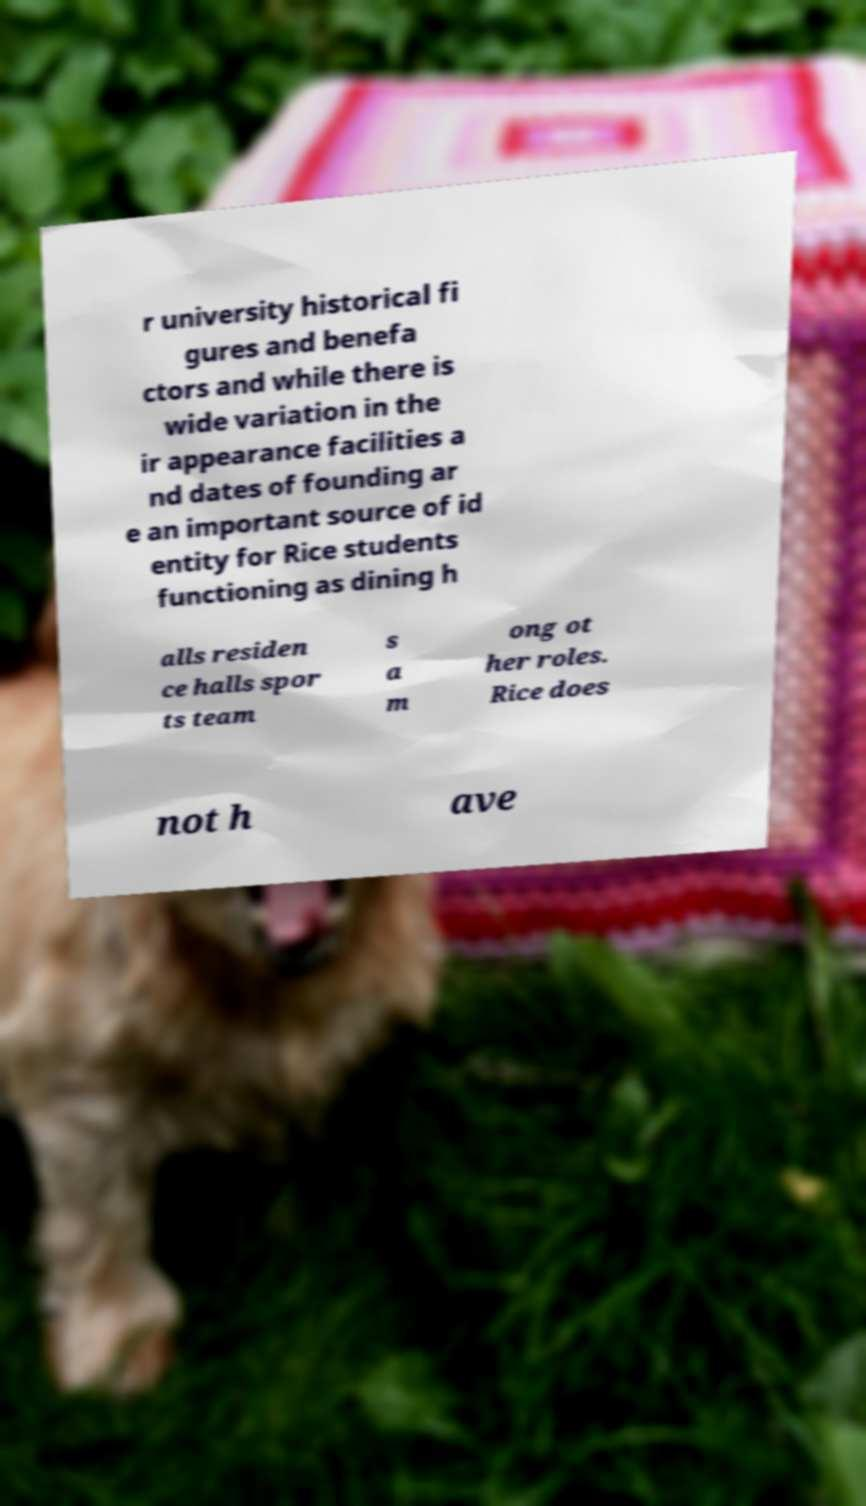I need the written content from this picture converted into text. Can you do that? r university historical fi gures and benefa ctors and while there is wide variation in the ir appearance facilities a nd dates of founding ar e an important source of id entity for Rice students functioning as dining h alls residen ce halls spor ts team s a m ong ot her roles. Rice does not h ave 